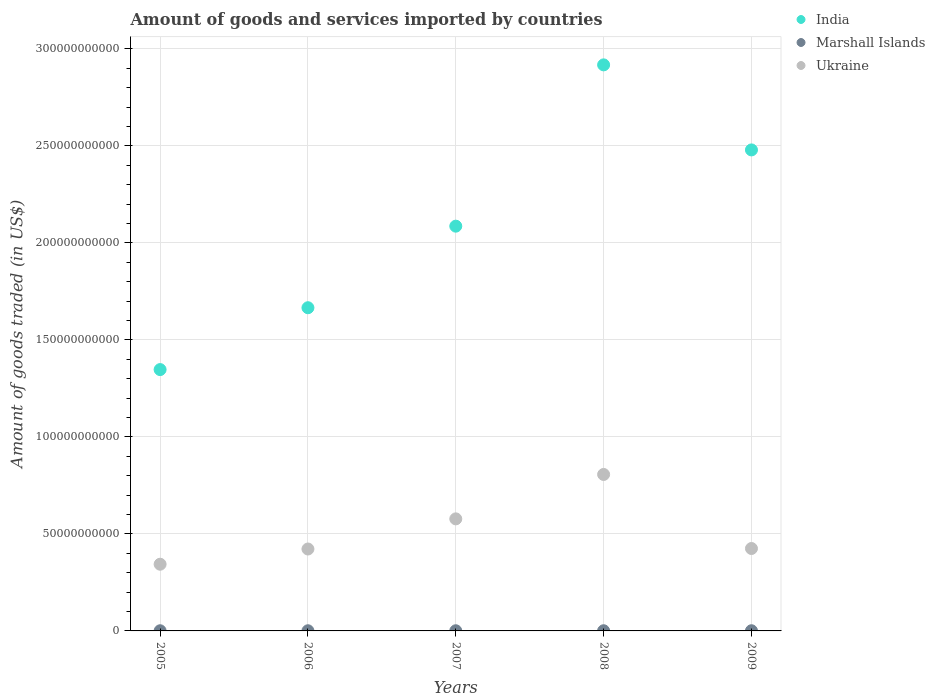How many different coloured dotlines are there?
Provide a short and direct response. 3. Is the number of dotlines equal to the number of legend labels?
Provide a short and direct response. Yes. What is the total amount of goods and services imported in India in 2005?
Provide a succinct answer. 1.35e+11. Across all years, what is the maximum total amount of goods and services imported in Marshall Islands?
Your answer should be compact. 9.43e+07. Across all years, what is the minimum total amount of goods and services imported in Ukraine?
Offer a very short reply. 3.44e+1. In which year was the total amount of goods and services imported in Marshall Islands maximum?
Make the answer very short. 2009. What is the total total amount of goods and services imported in India in the graph?
Make the answer very short. 1.05e+12. What is the difference between the total amount of goods and services imported in Ukraine in 2005 and that in 2006?
Give a very brief answer. -7.84e+09. What is the difference between the total amount of goods and services imported in India in 2005 and the total amount of goods and services imported in Ukraine in 2007?
Provide a succinct answer. 7.69e+1. What is the average total amount of goods and services imported in Marshall Islands per year?
Your response must be concise. 8.79e+07. In the year 2008, what is the difference between the total amount of goods and services imported in India and total amount of goods and services imported in Marshall Islands?
Provide a succinct answer. 2.92e+11. In how many years, is the total amount of goods and services imported in Marshall Islands greater than 50000000000 US$?
Ensure brevity in your answer.  0. What is the ratio of the total amount of goods and services imported in Ukraine in 2005 to that in 2006?
Your answer should be very brief. 0.81. Is the difference between the total amount of goods and services imported in India in 2007 and 2008 greater than the difference between the total amount of goods and services imported in Marshall Islands in 2007 and 2008?
Offer a very short reply. No. What is the difference between the highest and the second highest total amount of goods and services imported in India?
Your answer should be very brief. 4.38e+1. What is the difference between the highest and the lowest total amount of goods and services imported in India?
Give a very brief answer. 1.57e+11. Is the sum of the total amount of goods and services imported in India in 2006 and 2009 greater than the maximum total amount of goods and services imported in Marshall Islands across all years?
Make the answer very short. Yes. Does the total amount of goods and services imported in Ukraine monotonically increase over the years?
Provide a short and direct response. No. Is the total amount of goods and services imported in Ukraine strictly greater than the total amount of goods and services imported in Marshall Islands over the years?
Your response must be concise. Yes. Does the graph contain grids?
Provide a succinct answer. Yes. How many legend labels are there?
Keep it short and to the point. 3. How are the legend labels stacked?
Your answer should be compact. Vertical. What is the title of the graph?
Provide a short and direct response. Amount of goods and services imported by countries. Does "South Sudan" appear as one of the legend labels in the graph?
Ensure brevity in your answer.  No. What is the label or title of the Y-axis?
Your response must be concise. Amount of goods traded (in US$). What is the Amount of goods traded (in US$) in India in 2005?
Keep it short and to the point. 1.35e+11. What is the Amount of goods traded (in US$) in Marshall Islands in 2005?
Your response must be concise. 8.51e+07. What is the Amount of goods traded (in US$) in Ukraine in 2005?
Your answer should be compact. 3.44e+1. What is the Amount of goods traded (in US$) of India in 2006?
Make the answer very short. 1.67e+11. What is the Amount of goods traded (in US$) in Marshall Islands in 2006?
Give a very brief answer. 8.20e+07. What is the Amount of goods traded (in US$) of Ukraine in 2006?
Your answer should be very brief. 4.22e+1. What is the Amount of goods traded (in US$) of India in 2007?
Your response must be concise. 2.09e+11. What is the Amount of goods traded (in US$) in Marshall Islands in 2007?
Your answer should be compact. 8.79e+07. What is the Amount of goods traded (in US$) in Ukraine in 2007?
Offer a very short reply. 5.78e+1. What is the Amount of goods traded (in US$) of India in 2008?
Keep it short and to the point. 2.92e+11. What is the Amount of goods traded (in US$) in Marshall Islands in 2008?
Keep it short and to the point. 9.00e+07. What is the Amount of goods traded (in US$) in Ukraine in 2008?
Provide a short and direct response. 8.06e+1. What is the Amount of goods traded (in US$) of India in 2009?
Your answer should be very brief. 2.48e+11. What is the Amount of goods traded (in US$) of Marshall Islands in 2009?
Give a very brief answer. 9.43e+07. What is the Amount of goods traded (in US$) of Ukraine in 2009?
Your answer should be very brief. 4.25e+1. Across all years, what is the maximum Amount of goods traded (in US$) of India?
Ensure brevity in your answer.  2.92e+11. Across all years, what is the maximum Amount of goods traded (in US$) in Marshall Islands?
Provide a succinct answer. 9.43e+07. Across all years, what is the maximum Amount of goods traded (in US$) of Ukraine?
Provide a short and direct response. 8.06e+1. Across all years, what is the minimum Amount of goods traded (in US$) in India?
Your answer should be compact. 1.35e+11. Across all years, what is the minimum Amount of goods traded (in US$) of Marshall Islands?
Your answer should be compact. 8.20e+07. Across all years, what is the minimum Amount of goods traded (in US$) in Ukraine?
Make the answer very short. 3.44e+1. What is the total Amount of goods traded (in US$) of India in the graph?
Offer a terse response. 1.05e+12. What is the total Amount of goods traded (in US$) in Marshall Islands in the graph?
Keep it short and to the point. 4.39e+08. What is the total Amount of goods traded (in US$) in Ukraine in the graph?
Offer a terse response. 2.57e+11. What is the difference between the Amount of goods traded (in US$) of India in 2005 and that in 2006?
Offer a very short reply. -3.19e+1. What is the difference between the Amount of goods traded (in US$) in Marshall Islands in 2005 and that in 2006?
Your answer should be very brief. 3.16e+06. What is the difference between the Amount of goods traded (in US$) in Ukraine in 2005 and that in 2006?
Keep it short and to the point. -7.84e+09. What is the difference between the Amount of goods traded (in US$) of India in 2005 and that in 2007?
Make the answer very short. -7.39e+1. What is the difference between the Amount of goods traded (in US$) of Marshall Islands in 2005 and that in 2007?
Provide a succinct answer. -2.80e+06. What is the difference between the Amount of goods traded (in US$) in Ukraine in 2005 and that in 2007?
Your answer should be compact. -2.34e+1. What is the difference between the Amount of goods traded (in US$) in India in 2005 and that in 2008?
Keep it short and to the point. -1.57e+11. What is the difference between the Amount of goods traded (in US$) of Marshall Islands in 2005 and that in 2008?
Make the answer very short. -4.88e+06. What is the difference between the Amount of goods traded (in US$) in Ukraine in 2005 and that in 2008?
Your answer should be very brief. -4.63e+1. What is the difference between the Amount of goods traded (in US$) of India in 2005 and that in 2009?
Ensure brevity in your answer.  -1.13e+11. What is the difference between the Amount of goods traded (in US$) of Marshall Islands in 2005 and that in 2009?
Provide a succinct answer. -9.18e+06. What is the difference between the Amount of goods traded (in US$) of Ukraine in 2005 and that in 2009?
Provide a short and direct response. -8.10e+09. What is the difference between the Amount of goods traded (in US$) of India in 2006 and that in 2007?
Your response must be concise. -4.20e+1. What is the difference between the Amount of goods traded (in US$) in Marshall Islands in 2006 and that in 2007?
Ensure brevity in your answer.  -5.96e+06. What is the difference between the Amount of goods traded (in US$) in Ukraine in 2006 and that in 2007?
Give a very brief answer. -1.55e+1. What is the difference between the Amount of goods traded (in US$) in India in 2006 and that in 2008?
Provide a short and direct response. -1.25e+11. What is the difference between the Amount of goods traded (in US$) in Marshall Islands in 2006 and that in 2008?
Provide a succinct answer. -8.04e+06. What is the difference between the Amount of goods traded (in US$) in Ukraine in 2006 and that in 2008?
Provide a short and direct response. -3.84e+1. What is the difference between the Amount of goods traded (in US$) in India in 2006 and that in 2009?
Give a very brief answer. -8.13e+1. What is the difference between the Amount of goods traded (in US$) of Marshall Islands in 2006 and that in 2009?
Your answer should be compact. -1.23e+07. What is the difference between the Amount of goods traded (in US$) in Ukraine in 2006 and that in 2009?
Offer a very short reply. -2.57e+08. What is the difference between the Amount of goods traded (in US$) of India in 2007 and that in 2008?
Provide a short and direct response. -8.31e+1. What is the difference between the Amount of goods traded (in US$) of Marshall Islands in 2007 and that in 2008?
Your response must be concise. -2.08e+06. What is the difference between the Amount of goods traded (in US$) in Ukraine in 2007 and that in 2008?
Provide a short and direct response. -2.29e+1. What is the difference between the Amount of goods traded (in US$) of India in 2007 and that in 2009?
Provide a short and direct response. -3.93e+1. What is the difference between the Amount of goods traded (in US$) in Marshall Islands in 2007 and that in 2009?
Give a very brief answer. -6.38e+06. What is the difference between the Amount of goods traded (in US$) of Ukraine in 2007 and that in 2009?
Make the answer very short. 1.53e+1. What is the difference between the Amount of goods traded (in US$) in India in 2008 and that in 2009?
Provide a succinct answer. 4.38e+1. What is the difference between the Amount of goods traded (in US$) in Marshall Islands in 2008 and that in 2009?
Provide a succinct answer. -4.30e+06. What is the difference between the Amount of goods traded (in US$) of Ukraine in 2008 and that in 2009?
Provide a succinct answer. 3.82e+1. What is the difference between the Amount of goods traded (in US$) of India in 2005 and the Amount of goods traded (in US$) of Marshall Islands in 2006?
Offer a terse response. 1.35e+11. What is the difference between the Amount of goods traded (in US$) of India in 2005 and the Amount of goods traded (in US$) of Ukraine in 2006?
Offer a terse response. 9.25e+1. What is the difference between the Amount of goods traded (in US$) in Marshall Islands in 2005 and the Amount of goods traded (in US$) in Ukraine in 2006?
Provide a succinct answer. -4.21e+1. What is the difference between the Amount of goods traded (in US$) of India in 2005 and the Amount of goods traded (in US$) of Marshall Islands in 2007?
Your answer should be very brief. 1.35e+11. What is the difference between the Amount of goods traded (in US$) of India in 2005 and the Amount of goods traded (in US$) of Ukraine in 2007?
Offer a terse response. 7.69e+1. What is the difference between the Amount of goods traded (in US$) in Marshall Islands in 2005 and the Amount of goods traded (in US$) in Ukraine in 2007?
Provide a succinct answer. -5.77e+1. What is the difference between the Amount of goods traded (in US$) of India in 2005 and the Amount of goods traded (in US$) of Marshall Islands in 2008?
Ensure brevity in your answer.  1.35e+11. What is the difference between the Amount of goods traded (in US$) of India in 2005 and the Amount of goods traded (in US$) of Ukraine in 2008?
Keep it short and to the point. 5.41e+1. What is the difference between the Amount of goods traded (in US$) in Marshall Islands in 2005 and the Amount of goods traded (in US$) in Ukraine in 2008?
Provide a short and direct response. -8.06e+1. What is the difference between the Amount of goods traded (in US$) of India in 2005 and the Amount of goods traded (in US$) of Marshall Islands in 2009?
Offer a terse response. 1.35e+11. What is the difference between the Amount of goods traded (in US$) in India in 2005 and the Amount of goods traded (in US$) in Ukraine in 2009?
Provide a short and direct response. 9.22e+1. What is the difference between the Amount of goods traded (in US$) in Marshall Islands in 2005 and the Amount of goods traded (in US$) in Ukraine in 2009?
Your response must be concise. -4.24e+1. What is the difference between the Amount of goods traded (in US$) of India in 2006 and the Amount of goods traded (in US$) of Marshall Islands in 2007?
Give a very brief answer. 1.66e+11. What is the difference between the Amount of goods traded (in US$) in India in 2006 and the Amount of goods traded (in US$) in Ukraine in 2007?
Your response must be concise. 1.09e+11. What is the difference between the Amount of goods traded (in US$) of Marshall Islands in 2006 and the Amount of goods traded (in US$) of Ukraine in 2007?
Provide a short and direct response. -5.77e+1. What is the difference between the Amount of goods traded (in US$) in India in 2006 and the Amount of goods traded (in US$) in Marshall Islands in 2008?
Provide a short and direct response. 1.66e+11. What is the difference between the Amount of goods traded (in US$) of India in 2006 and the Amount of goods traded (in US$) of Ukraine in 2008?
Your response must be concise. 8.59e+1. What is the difference between the Amount of goods traded (in US$) in Marshall Islands in 2006 and the Amount of goods traded (in US$) in Ukraine in 2008?
Your answer should be compact. -8.06e+1. What is the difference between the Amount of goods traded (in US$) of India in 2006 and the Amount of goods traded (in US$) of Marshall Islands in 2009?
Give a very brief answer. 1.66e+11. What is the difference between the Amount of goods traded (in US$) in India in 2006 and the Amount of goods traded (in US$) in Ukraine in 2009?
Your answer should be very brief. 1.24e+11. What is the difference between the Amount of goods traded (in US$) of Marshall Islands in 2006 and the Amount of goods traded (in US$) of Ukraine in 2009?
Your answer should be compact. -4.24e+1. What is the difference between the Amount of goods traded (in US$) of India in 2007 and the Amount of goods traded (in US$) of Marshall Islands in 2008?
Your answer should be compact. 2.09e+11. What is the difference between the Amount of goods traded (in US$) in India in 2007 and the Amount of goods traded (in US$) in Ukraine in 2008?
Keep it short and to the point. 1.28e+11. What is the difference between the Amount of goods traded (in US$) in Marshall Islands in 2007 and the Amount of goods traded (in US$) in Ukraine in 2008?
Offer a very short reply. -8.06e+1. What is the difference between the Amount of goods traded (in US$) in India in 2007 and the Amount of goods traded (in US$) in Marshall Islands in 2009?
Give a very brief answer. 2.09e+11. What is the difference between the Amount of goods traded (in US$) in India in 2007 and the Amount of goods traded (in US$) in Ukraine in 2009?
Your response must be concise. 1.66e+11. What is the difference between the Amount of goods traded (in US$) of Marshall Islands in 2007 and the Amount of goods traded (in US$) of Ukraine in 2009?
Your answer should be compact. -4.24e+1. What is the difference between the Amount of goods traded (in US$) of India in 2008 and the Amount of goods traded (in US$) of Marshall Islands in 2009?
Offer a terse response. 2.92e+11. What is the difference between the Amount of goods traded (in US$) in India in 2008 and the Amount of goods traded (in US$) in Ukraine in 2009?
Give a very brief answer. 2.49e+11. What is the difference between the Amount of goods traded (in US$) in Marshall Islands in 2008 and the Amount of goods traded (in US$) in Ukraine in 2009?
Provide a succinct answer. -4.24e+1. What is the average Amount of goods traded (in US$) in India per year?
Your answer should be very brief. 2.10e+11. What is the average Amount of goods traded (in US$) in Marshall Islands per year?
Offer a very short reply. 8.79e+07. What is the average Amount of goods traded (in US$) in Ukraine per year?
Make the answer very short. 5.15e+1. In the year 2005, what is the difference between the Amount of goods traded (in US$) of India and Amount of goods traded (in US$) of Marshall Islands?
Offer a very short reply. 1.35e+11. In the year 2005, what is the difference between the Amount of goods traded (in US$) of India and Amount of goods traded (in US$) of Ukraine?
Make the answer very short. 1.00e+11. In the year 2005, what is the difference between the Amount of goods traded (in US$) in Marshall Islands and Amount of goods traded (in US$) in Ukraine?
Offer a very short reply. -3.43e+1. In the year 2006, what is the difference between the Amount of goods traded (in US$) in India and Amount of goods traded (in US$) in Marshall Islands?
Offer a terse response. 1.66e+11. In the year 2006, what is the difference between the Amount of goods traded (in US$) in India and Amount of goods traded (in US$) in Ukraine?
Offer a very short reply. 1.24e+11. In the year 2006, what is the difference between the Amount of goods traded (in US$) of Marshall Islands and Amount of goods traded (in US$) of Ukraine?
Make the answer very short. -4.21e+1. In the year 2007, what is the difference between the Amount of goods traded (in US$) of India and Amount of goods traded (in US$) of Marshall Islands?
Ensure brevity in your answer.  2.09e+11. In the year 2007, what is the difference between the Amount of goods traded (in US$) of India and Amount of goods traded (in US$) of Ukraine?
Make the answer very short. 1.51e+11. In the year 2007, what is the difference between the Amount of goods traded (in US$) of Marshall Islands and Amount of goods traded (in US$) of Ukraine?
Ensure brevity in your answer.  -5.77e+1. In the year 2008, what is the difference between the Amount of goods traded (in US$) in India and Amount of goods traded (in US$) in Marshall Islands?
Your answer should be very brief. 2.92e+11. In the year 2008, what is the difference between the Amount of goods traded (in US$) of India and Amount of goods traded (in US$) of Ukraine?
Provide a succinct answer. 2.11e+11. In the year 2008, what is the difference between the Amount of goods traded (in US$) of Marshall Islands and Amount of goods traded (in US$) of Ukraine?
Your answer should be compact. -8.05e+1. In the year 2009, what is the difference between the Amount of goods traded (in US$) in India and Amount of goods traded (in US$) in Marshall Islands?
Your answer should be compact. 2.48e+11. In the year 2009, what is the difference between the Amount of goods traded (in US$) of India and Amount of goods traded (in US$) of Ukraine?
Offer a terse response. 2.05e+11. In the year 2009, what is the difference between the Amount of goods traded (in US$) of Marshall Islands and Amount of goods traded (in US$) of Ukraine?
Make the answer very short. -4.24e+1. What is the ratio of the Amount of goods traded (in US$) in India in 2005 to that in 2006?
Offer a very short reply. 0.81. What is the ratio of the Amount of goods traded (in US$) in Ukraine in 2005 to that in 2006?
Make the answer very short. 0.81. What is the ratio of the Amount of goods traded (in US$) of India in 2005 to that in 2007?
Ensure brevity in your answer.  0.65. What is the ratio of the Amount of goods traded (in US$) of Marshall Islands in 2005 to that in 2007?
Offer a terse response. 0.97. What is the ratio of the Amount of goods traded (in US$) of Ukraine in 2005 to that in 2007?
Offer a very short reply. 0.6. What is the ratio of the Amount of goods traded (in US$) of India in 2005 to that in 2008?
Offer a terse response. 0.46. What is the ratio of the Amount of goods traded (in US$) of Marshall Islands in 2005 to that in 2008?
Offer a very short reply. 0.95. What is the ratio of the Amount of goods traded (in US$) in Ukraine in 2005 to that in 2008?
Offer a terse response. 0.43. What is the ratio of the Amount of goods traded (in US$) of India in 2005 to that in 2009?
Your response must be concise. 0.54. What is the ratio of the Amount of goods traded (in US$) in Marshall Islands in 2005 to that in 2009?
Your answer should be very brief. 0.9. What is the ratio of the Amount of goods traded (in US$) of Ukraine in 2005 to that in 2009?
Ensure brevity in your answer.  0.81. What is the ratio of the Amount of goods traded (in US$) in India in 2006 to that in 2007?
Provide a succinct answer. 0.8. What is the ratio of the Amount of goods traded (in US$) of Marshall Islands in 2006 to that in 2007?
Make the answer very short. 0.93. What is the ratio of the Amount of goods traded (in US$) in Ukraine in 2006 to that in 2007?
Your answer should be compact. 0.73. What is the ratio of the Amount of goods traded (in US$) of India in 2006 to that in 2008?
Ensure brevity in your answer.  0.57. What is the ratio of the Amount of goods traded (in US$) of Marshall Islands in 2006 to that in 2008?
Provide a succinct answer. 0.91. What is the ratio of the Amount of goods traded (in US$) of Ukraine in 2006 to that in 2008?
Your answer should be very brief. 0.52. What is the ratio of the Amount of goods traded (in US$) of India in 2006 to that in 2009?
Ensure brevity in your answer.  0.67. What is the ratio of the Amount of goods traded (in US$) of Marshall Islands in 2006 to that in 2009?
Keep it short and to the point. 0.87. What is the ratio of the Amount of goods traded (in US$) of Ukraine in 2006 to that in 2009?
Ensure brevity in your answer.  0.99. What is the ratio of the Amount of goods traded (in US$) of India in 2007 to that in 2008?
Provide a short and direct response. 0.72. What is the ratio of the Amount of goods traded (in US$) in Marshall Islands in 2007 to that in 2008?
Provide a short and direct response. 0.98. What is the ratio of the Amount of goods traded (in US$) of Ukraine in 2007 to that in 2008?
Provide a succinct answer. 0.72. What is the ratio of the Amount of goods traded (in US$) in India in 2007 to that in 2009?
Ensure brevity in your answer.  0.84. What is the ratio of the Amount of goods traded (in US$) in Marshall Islands in 2007 to that in 2009?
Offer a terse response. 0.93. What is the ratio of the Amount of goods traded (in US$) of Ukraine in 2007 to that in 2009?
Offer a very short reply. 1.36. What is the ratio of the Amount of goods traded (in US$) in India in 2008 to that in 2009?
Your answer should be compact. 1.18. What is the ratio of the Amount of goods traded (in US$) in Marshall Islands in 2008 to that in 2009?
Provide a short and direct response. 0.95. What is the ratio of the Amount of goods traded (in US$) in Ukraine in 2008 to that in 2009?
Provide a short and direct response. 1.9. What is the difference between the highest and the second highest Amount of goods traded (in US$) of India?
Your answer should be compact. 4.38e+1. What is the difference between the highest and the second highest Amount of goods traded (in US$) in Marshall Islands?
Your answer should be compact. 4.30e+06. What is the difference between the highest and the second highest Amount of goods traded (in US$) of Ukraine?
Make the answer very short. 2.29e+1. What is the difference between the highest and the lowest Amount of goods traded (in US$) in India?
Keep it short and to the point. 1.57e+11. What is the difference between the highest and the lowest Amount of goods traded (in US$) of Marshall Islands?
Provide a short and direct response. 1.23e+07. What is the difference between the highest and the lowest Amount of goods traded (in US$) in Ukraine?
Provide a short and direct response. 4.63e+1. 